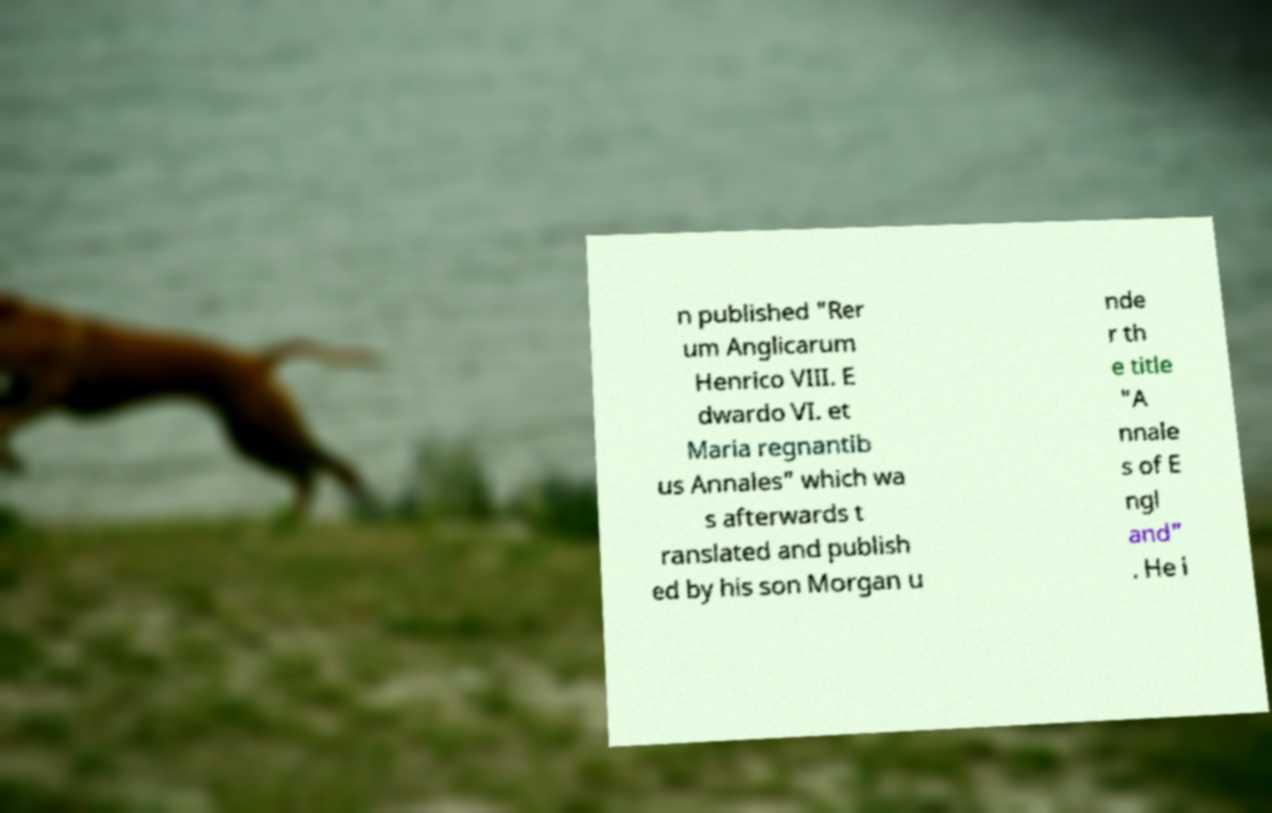Can you read and provide the text displayed in the image?This photo seems to have some interesting text. Can you extract and type it out for me? n published "Rer um Anglicarum Henrico VIII. E dwardo VI. et Maria regnantib us Annales" which wa s afterwards t ranslated and publish ed by his son Morgan u nde r th e title "A nnale s of E ngl and" . He i 